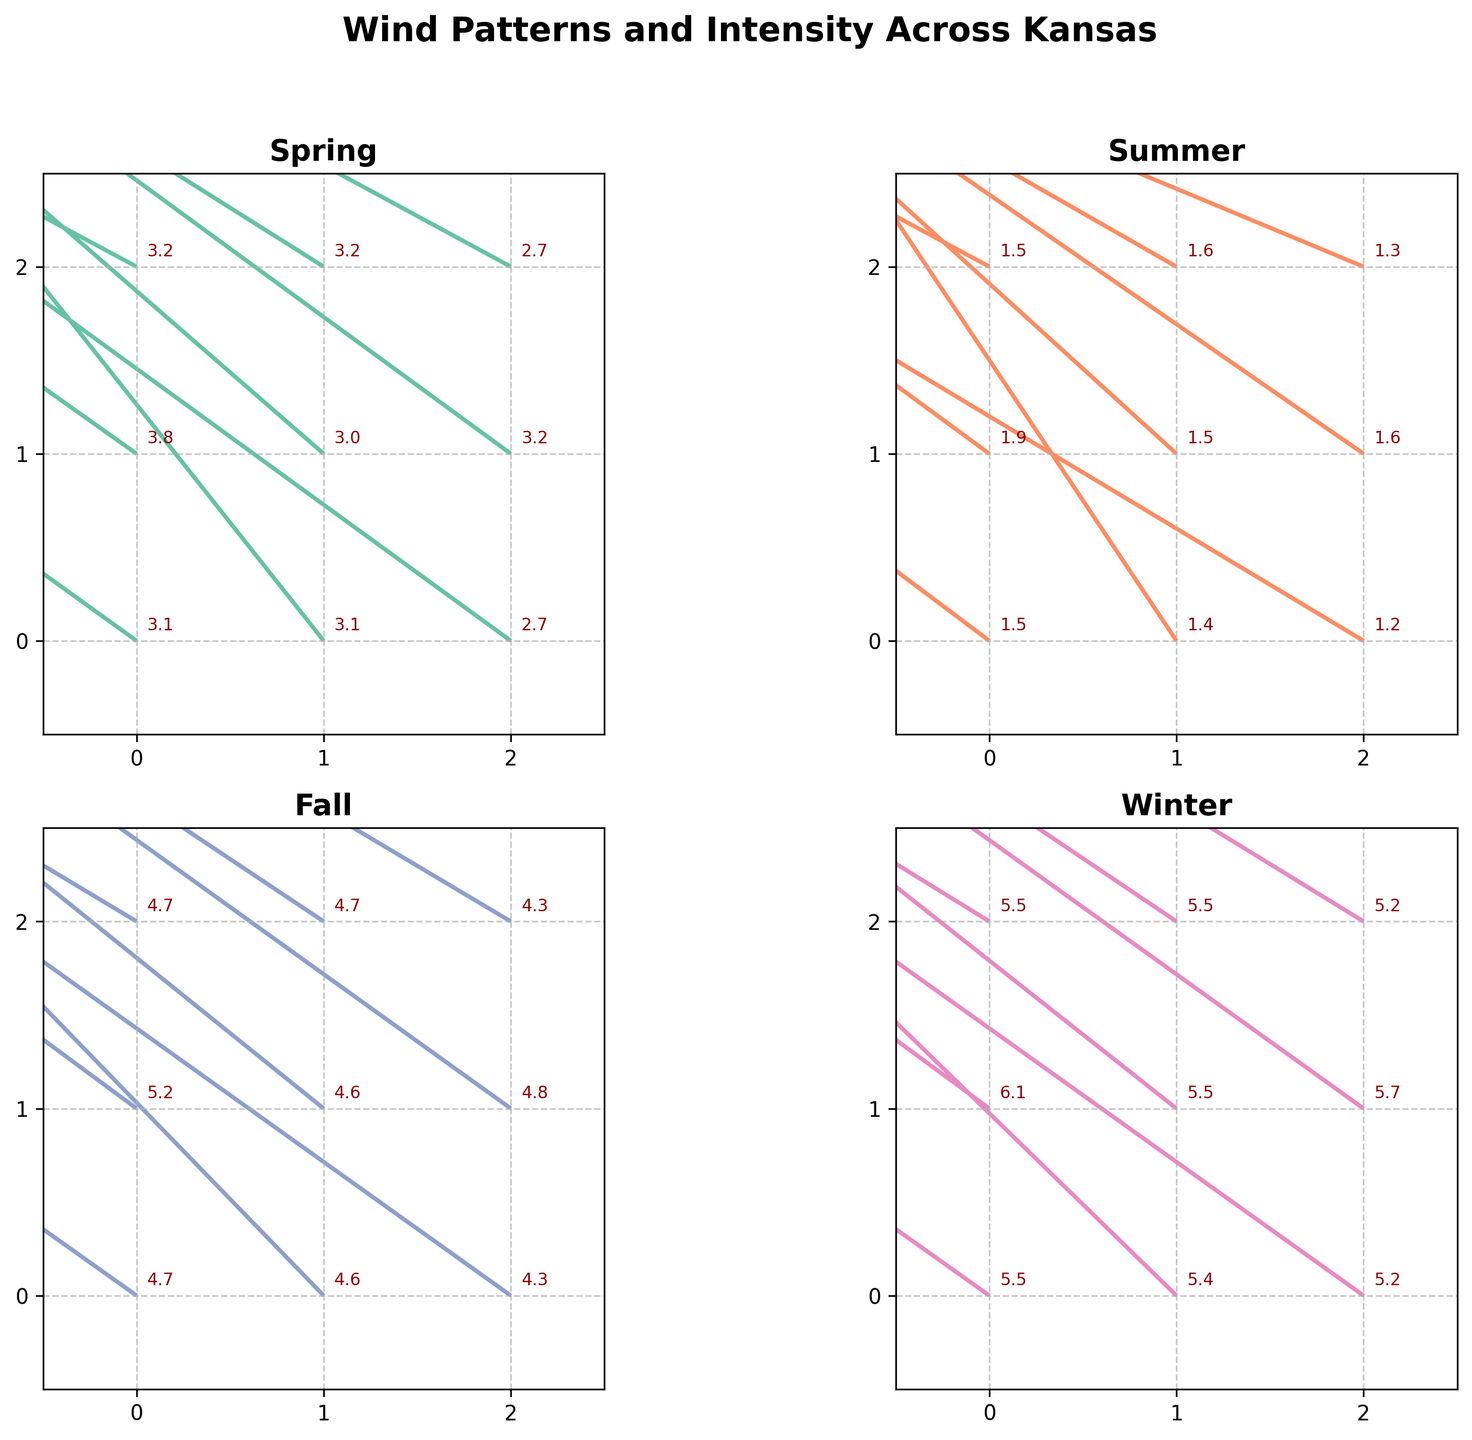What's the title of the figure? The title is located at the top center of the figure in bold font.
Answer: Wind Patterns and Intensity Across Kansas How many seasons are illustrated in the figure? There are four quiver plots shown, each representing a different season. The titles of the plots are Spring, Summer, Fall, and Winter.
Answer: 4 Which season shows the smallest wind vectors in general? Looking at all the quiver plots, Summer has the smallest wind arrows, indicating lower wind intensity.
Answer: Summer What is the color of the quiver plot for Fall? The quiver plot for Fall is colored in shades of a third unique color among the four. In this case, it’s a shade of blue/purple.
Answer: blue/purple During which season does the wind at position (1,0) have the highest speed? To determine this, we look at the quiver vectors at position (1,0) for each season and calculate the wind speed. Winter has the vector (-3.9, 3.8), with speed sqrt(3.9^2 + 3.8^2) = 5.4 (approximately). This is higher than the speeds in other seasons.
Answer: Winter What's the wind speed magnitude at position (2,1) in Summer? The vector at (2,1) in Summer is (-1.3, 0.9). Calculating the magnitude: sqrt((-1.3)^2 + (0.9)^2) = sqrt(1.69 + 0.81) = 1.6 (approximately).
Answer: 1.6 Compare the wind speed at position (1,2) between Spring and Fall. Which is stronger? Calculating the magnitudes for Spring (-2.7, 1.7) and Fall (-3.9, 2.6):
Spring: sqrt(2.7^2 + 1.7^2) = sqrt(7.29 + 2.89) = sqrt(10.18) ≈ 3.2
Fall: sqrt(3.9^2 + 2.6^2) = sqrt(15.21 + 6.76) = sqrt(21.97) ≈ 4.7
The wind is stronger in Fall.
Answer: Fall On average, which season has the highest wind speed magnitude? Calculating the average magnitude for each season:
Spring: (sum of all magnitudes) / 9 ≈ (3.0 avg per vector)
Summer: (sum of all magnitudes) / 9 ≈ (1.1 avg per vector)
Fall: (sum of all magnitudes) / 9 ≈ (4.2 avg per vector)
Winter: (sum of all magnitudes) / 9 ≈ (5.2 avg per vector)
Winter has the highest average wind speed.
Answer: Winter What visual features ensure the quiver plots are comparable across seasons? Each plot has the same axis limits, grid lines, and annotation for wind speed ensuring direct comparability across all seasons.
Answer: Consistent axis, grid lines, and annotations 